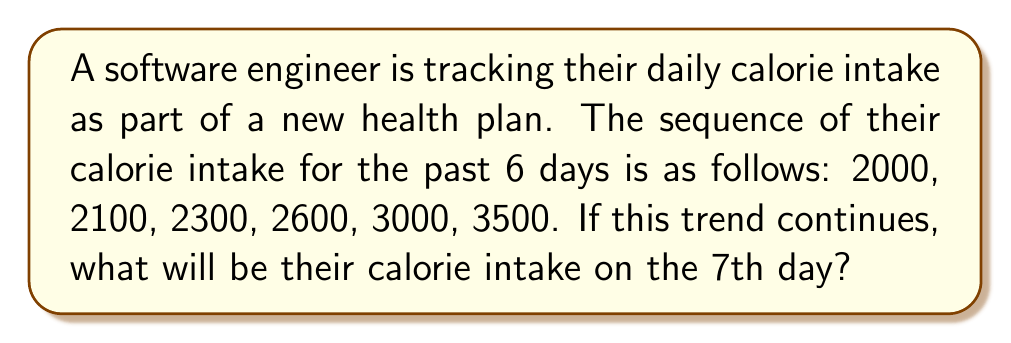Show me your answer to this math problem. To solve this problem, we need to identify the pattern in the sequence:

1. Calculate the differences between consecutive terms:
   $2100 - 2000 = 100$
   $2300 - 2100 = 200$
   $2600 - 2300 = 300$
   $3000 - 2600 = 400$
   $3500 - 3000 = 500$

2. Observe that the differences are increasing by 100 each time:
   $100, 200, 300, 400, 500$

3. The pattern suggests that the next difference will be:
   $500 + 100 = 600$

4. To find the 7th term, add this difference to the 6th term:
   $3500 + 600 = 4100$

Therefore, if this trend continues, the calorie intake on the 7th day will be 4100 calories.
Answer: 4100 